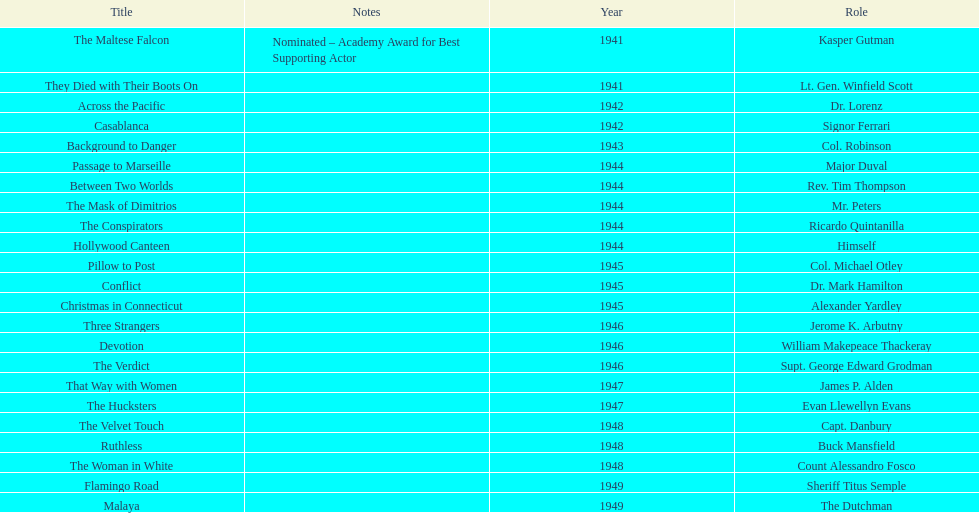Help me parse the entirety of this table. {'header': ['Title', 'Notes', 'Year', 'Role'], 'rows': [['The Maltese Falcon', 'Nominated – Academy Award for Best Supporting Actor', '1941', 'Kasper Gutman'], ['They Died with Their Boots On', '', '1941', 'Lt. Gen. Winfield Scott'], ['Across the Pacific', '', '1942', 'Dr. Lorenz'], ['Casablanca', '', '1942', 'Signor Ferrari'], ['Background to Danger', '', '1943', 'Col. Robinson'], ['Passage to Marseille', '', '1944', 'Major Duval'], ['Between Two Worlds', '', '1944', 'Rev. Tim Thompson'], ['The Mask of Dimitrios', '', '1944', 'Mr. Peters'], ['The Conspirators', '', '1944', 'Ricardo Quintanilla'], ['Hollywood Canteen', '', '1944', 'Himself'], ['Pillow to Post', '', '1945', 'Col. Michael Otley'], ['Conflict', '', '1945', 'Dr. Mark Hamilton'], ['Christmas in Connecticut', '', '1945', 'Alexander Yardley'], ['Three Strangers', '', '1946', 'Jerome K. Arbutny'], ['Devotion', '', '1946', 'William Makepeace Thackeray'], ['The Verdict', '', '1946', 'Supt. George Edward Grodman'], ['That Way with Women', '', '1947', 'James P. Alden'], ['The Hucksters', '', '1947', 'Evan Llewellyn Evans'], ['The Velvet Touch', '', '1948', 'Capt. Danbury'], ['Ruthless', '', '1948', 'Buck Mansfield'], ['The Woman in White', '', '1948', 'Count Alessandro Fosco'], ['Flamingo Road', '', '1949', 'Sheriff Titus Semple'], ['Malaya', '', '1949', 'The Dutchman']]} What were the first and last movies greenstreet acted in? The Maltese Falcon, Malaya. 